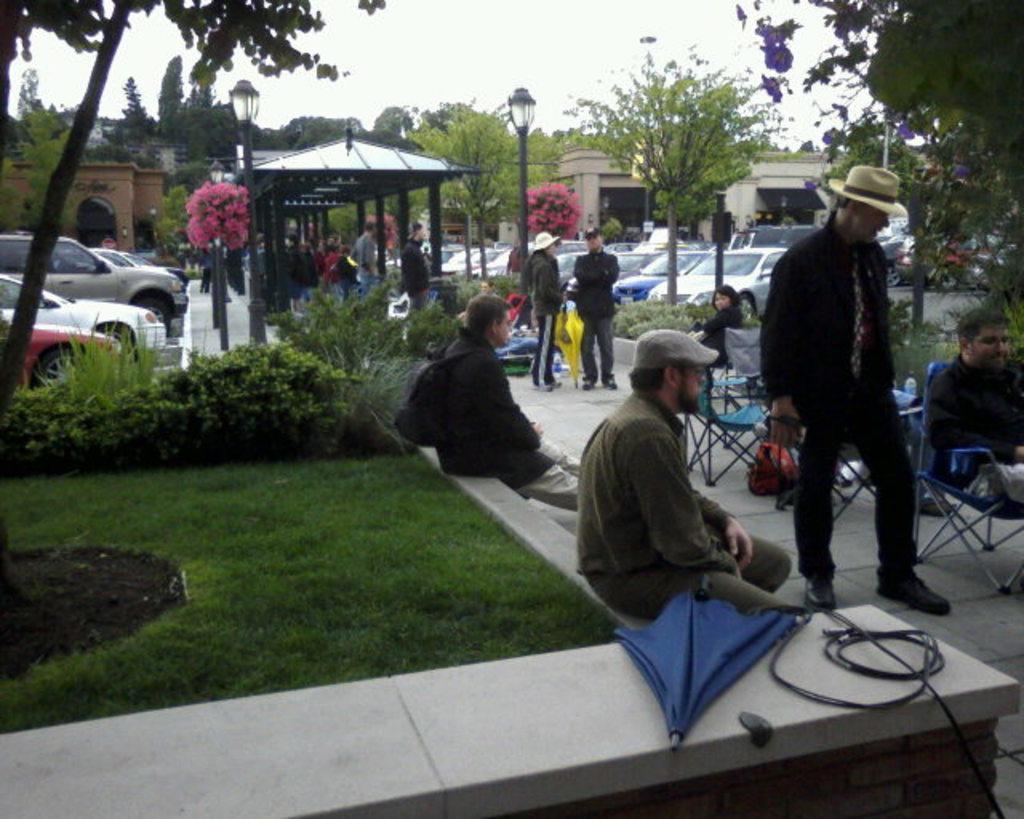Can you describe this image briefly? In the foreground of this image, there are two men sitting on the stone surface and also we can see an umbrella and a cable. On the left, there is grass, a tree and few plants. On the right, there is a man sitting on the chair, a man standing, chairs and few objects. In the background, there are trees, poles, people, shed, vehicles, building and the sky. 